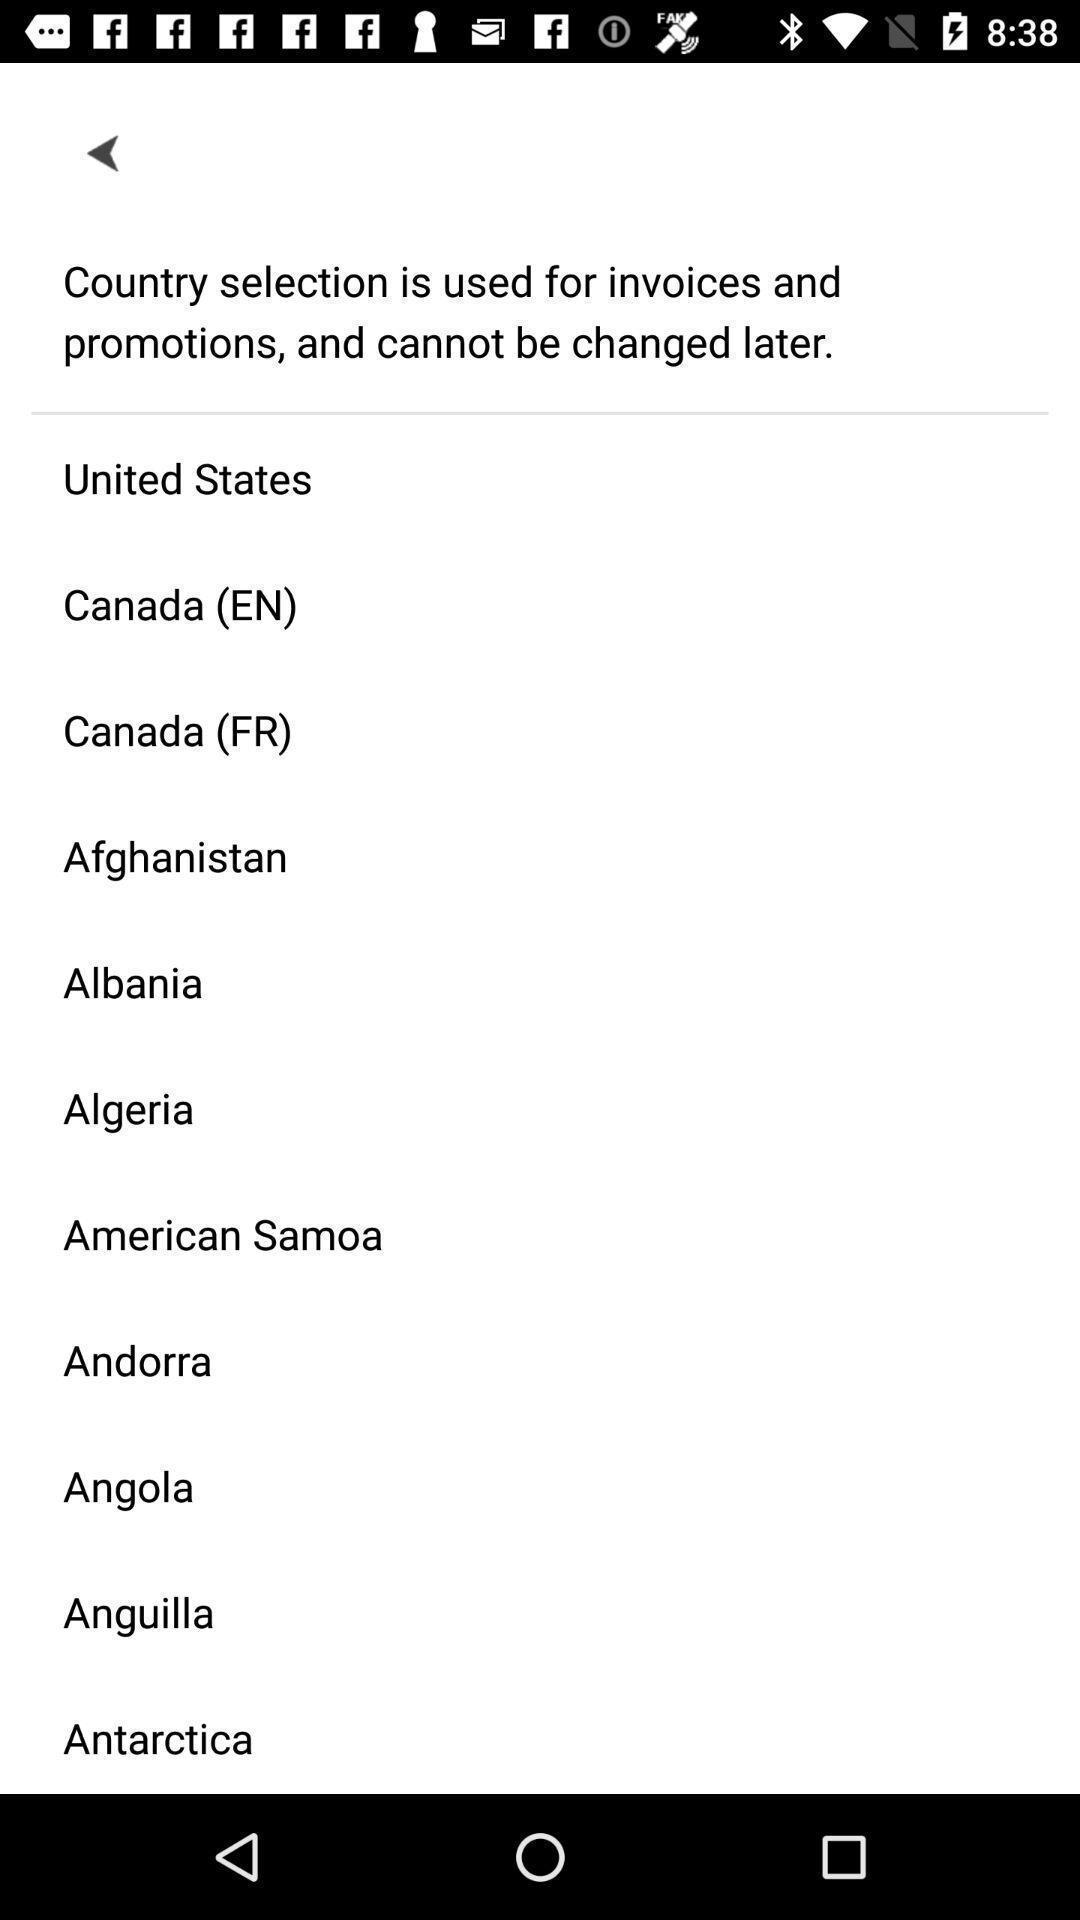Describe the key features of this screenshot. Screen showing list of countries. 